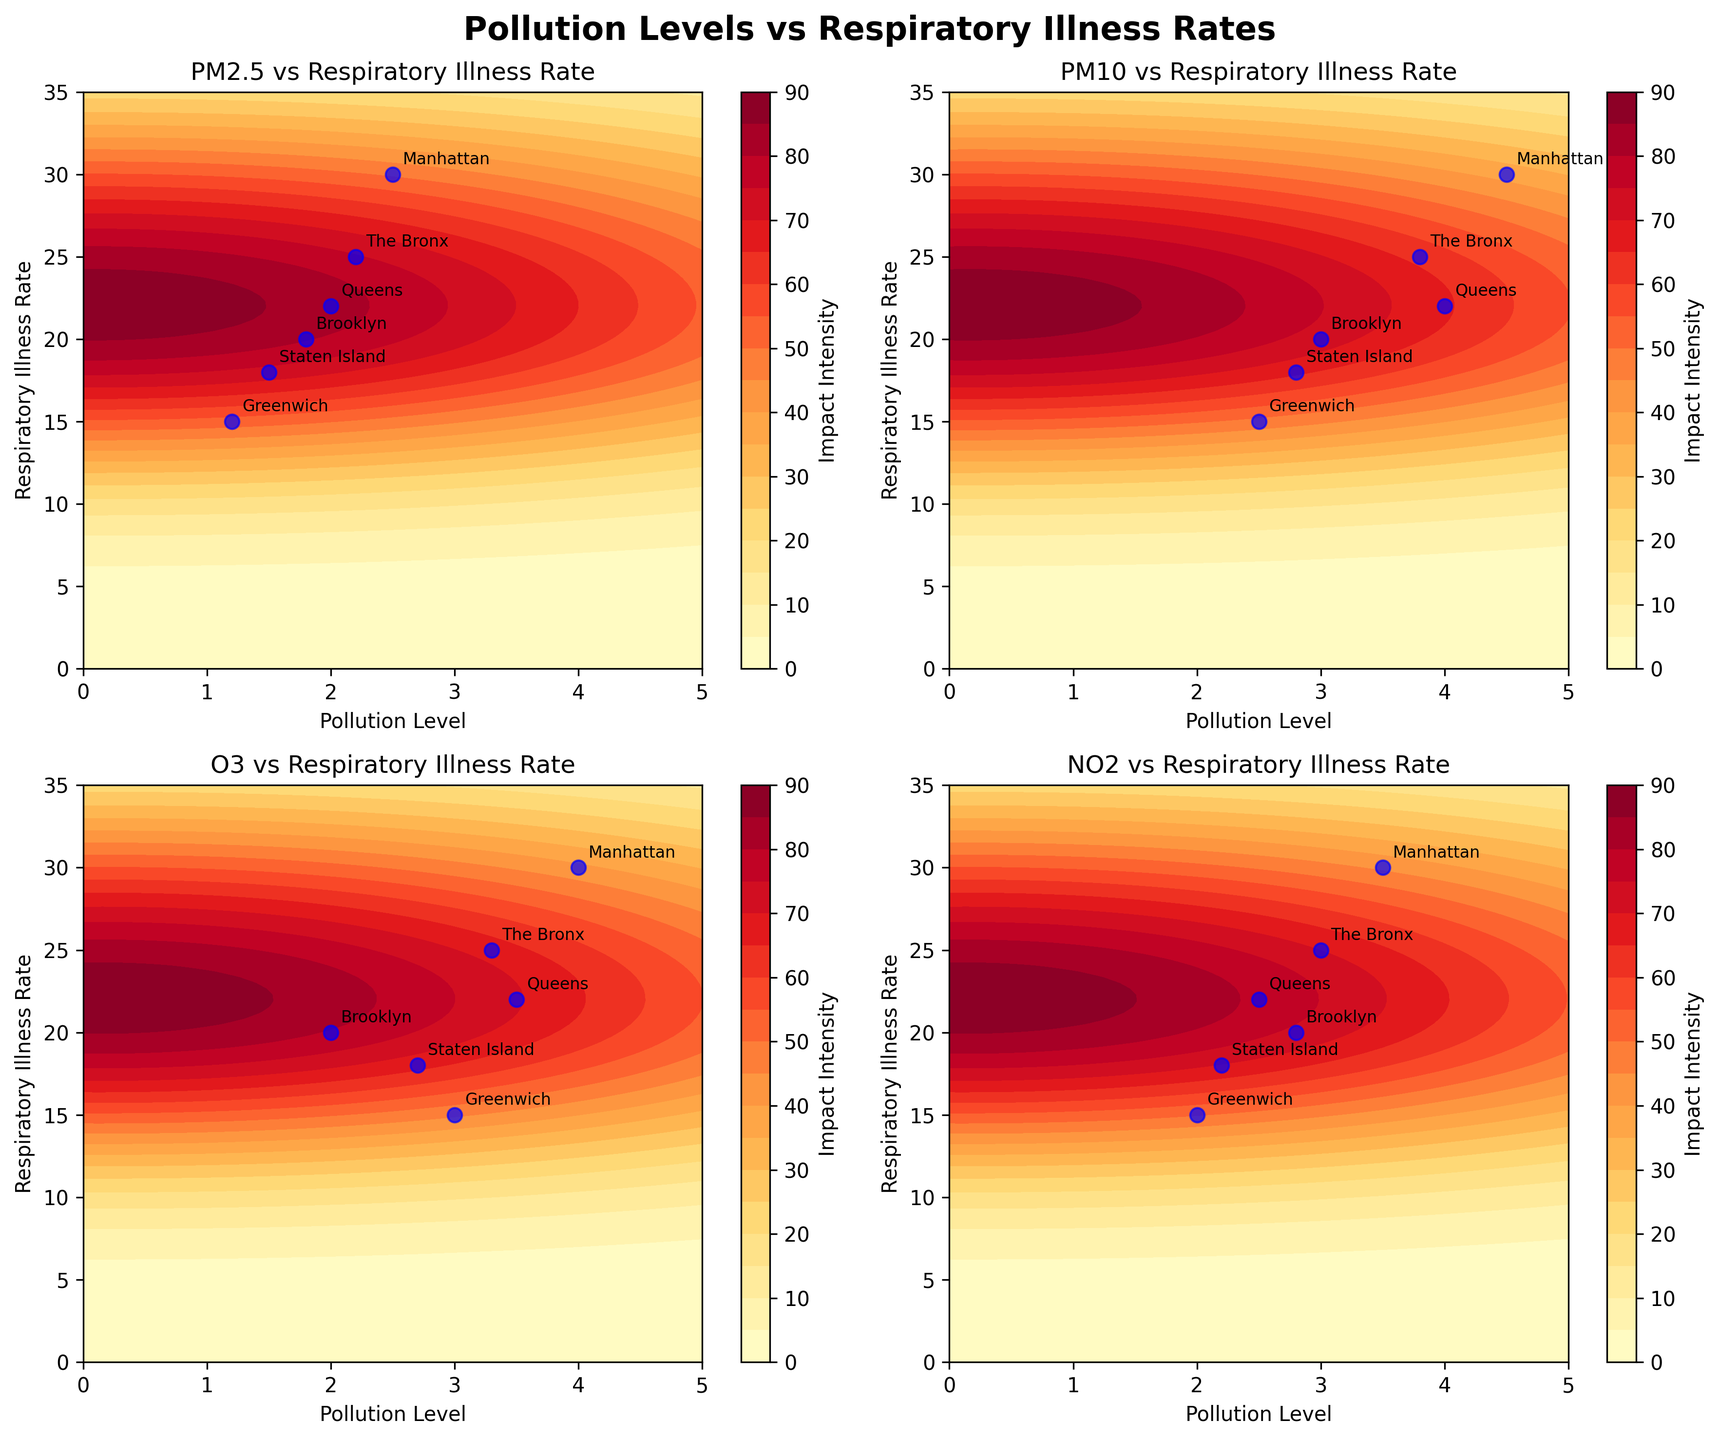How many subplots are there in the figure? There are 2 rows and 2 columns of subplots, making a total of 4 subplots.
Answer: 4 What is the title of the figure? The title is written in bold at the top center of the figure.
Answer: Pollution Levels vs Respiratory Illness Rates Which neighborhood has the highest respiratory illness rate? By looking at the data points, Manhattan is highest along the respiratory illness rate axis.
Answer: Manhattan How many neighborhoods are annotated in each subplot? Each subplot contains annotations for six neighborhoods: Greenwich, Brooklyn, Queens, Manhattan, The Bronx, and Staten Island.
Answer: 6 Which pollutant appears to have the strongest contour impact on respiratory illness rates? By visual inspection, the subplot for NO2 shows more intense contour levels over a wider area, indicating a strong impact.
Answer: NO2 What is the pollution level range shown on the x-axis? The x-axis ranges from 0 to 5, as depicted in each subplot.
Answer: 0 to 5 Which neighborhood appears closest to the origin in the PM2.5 subplot? In the PM2.5 subplot, Greenwich appears closest to the origin, as it has the lowest pollution level and a low respiratory illness rate.
Answer: Greenwich For the O3 pollutant, which neighborhood has the lowest respiratory illness rate? By examining the O3 subplot, Greenwich has the lowest respiratory illness rate.
Answer: Greenwich Between Queens and Brooklyn, which has a higher respiratory illness rate for PM10 levels? In the PM10 subplot, Queens appears higher up on the y-axis compared to Brooklyn, indicating a higher respiratory illness rate.
Answer: Queens Comparing the PM2.5 and PM10 subplots, which neighborhood has a respiratory illness rate closest to 20 for both pollutants? Brooklyn stands out as having a respiratory illness rate of around 20 for both PM2.5 and PM10.
Answer: Brooklyn 